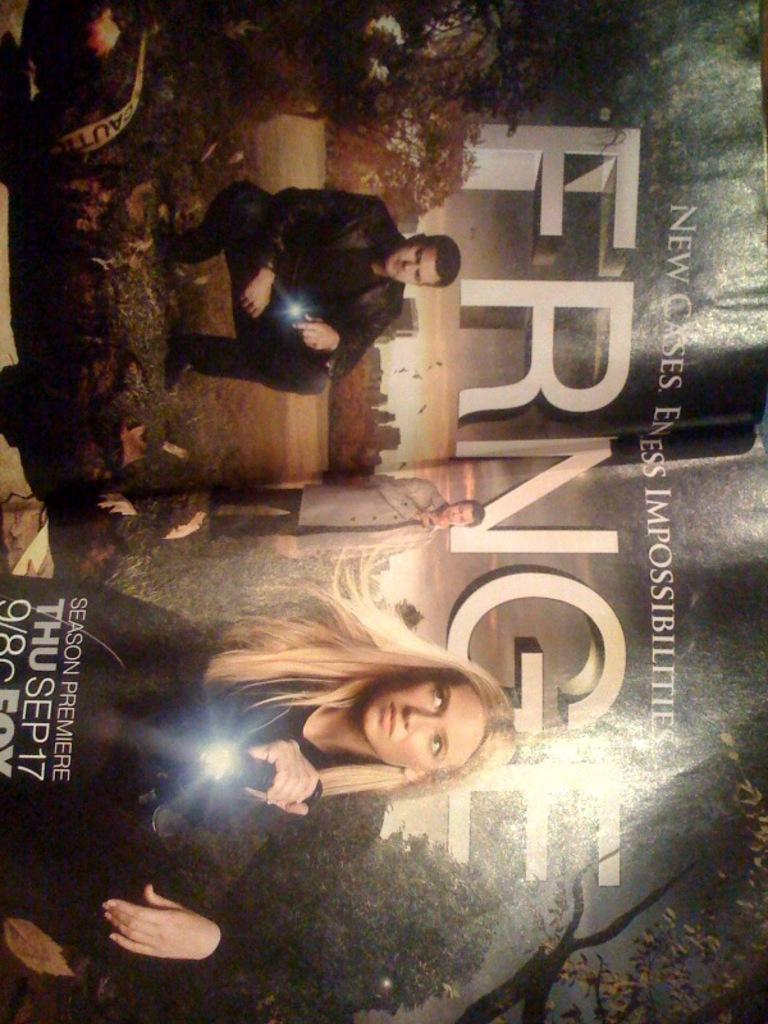<image>
Relay a brief, clear account of the picture shown. Ad for tv show Fringe Thur Sept 17. 